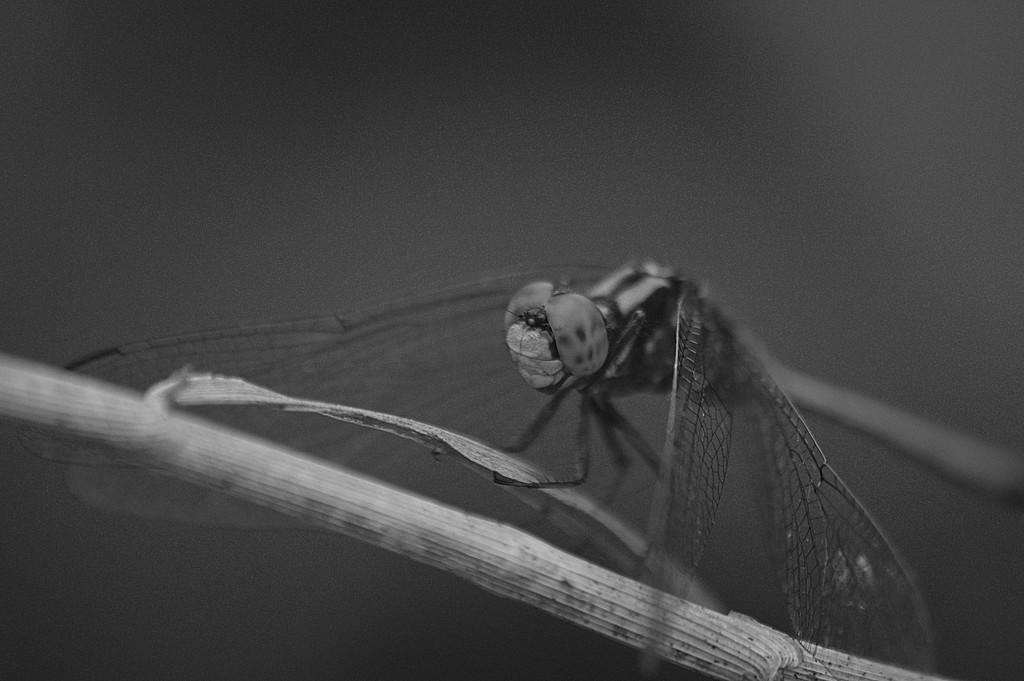What insect is present in the image? There is a dragonfly in the image. Where is the dragonfly located? The dragonfly is on the branch of a plant. What type of roll does the dragonfly's brother prefer? There is no mention of a roll or a brother in the image, so this question cannot be answered. 